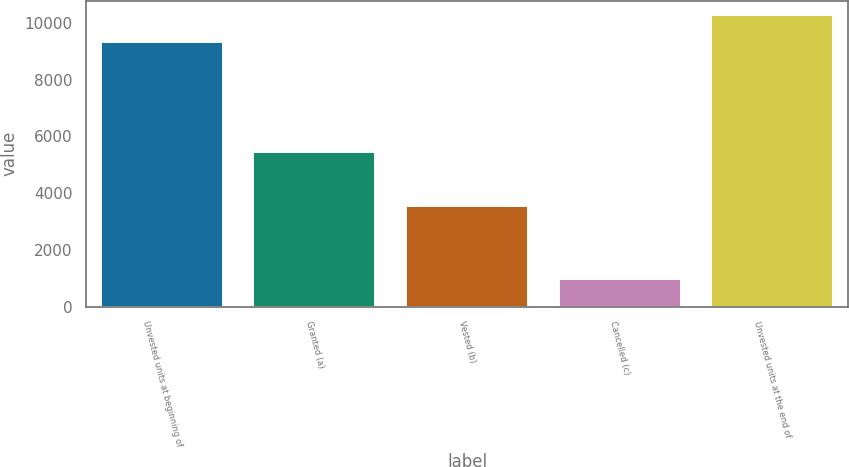Convert chart. <chart><loc_0><loc_0><loc_500><loc_500><bar_chart><fcel>Unvested units at beginning of<fcel>Granted (a)<fcel>Vested (b)<fcel>Cancelled (c)<fcel>Unvested units at the end of<nl><fcel>9341<fcel>5445<fcel>3534<fcel>972<fcel>10280<nl></chart> 